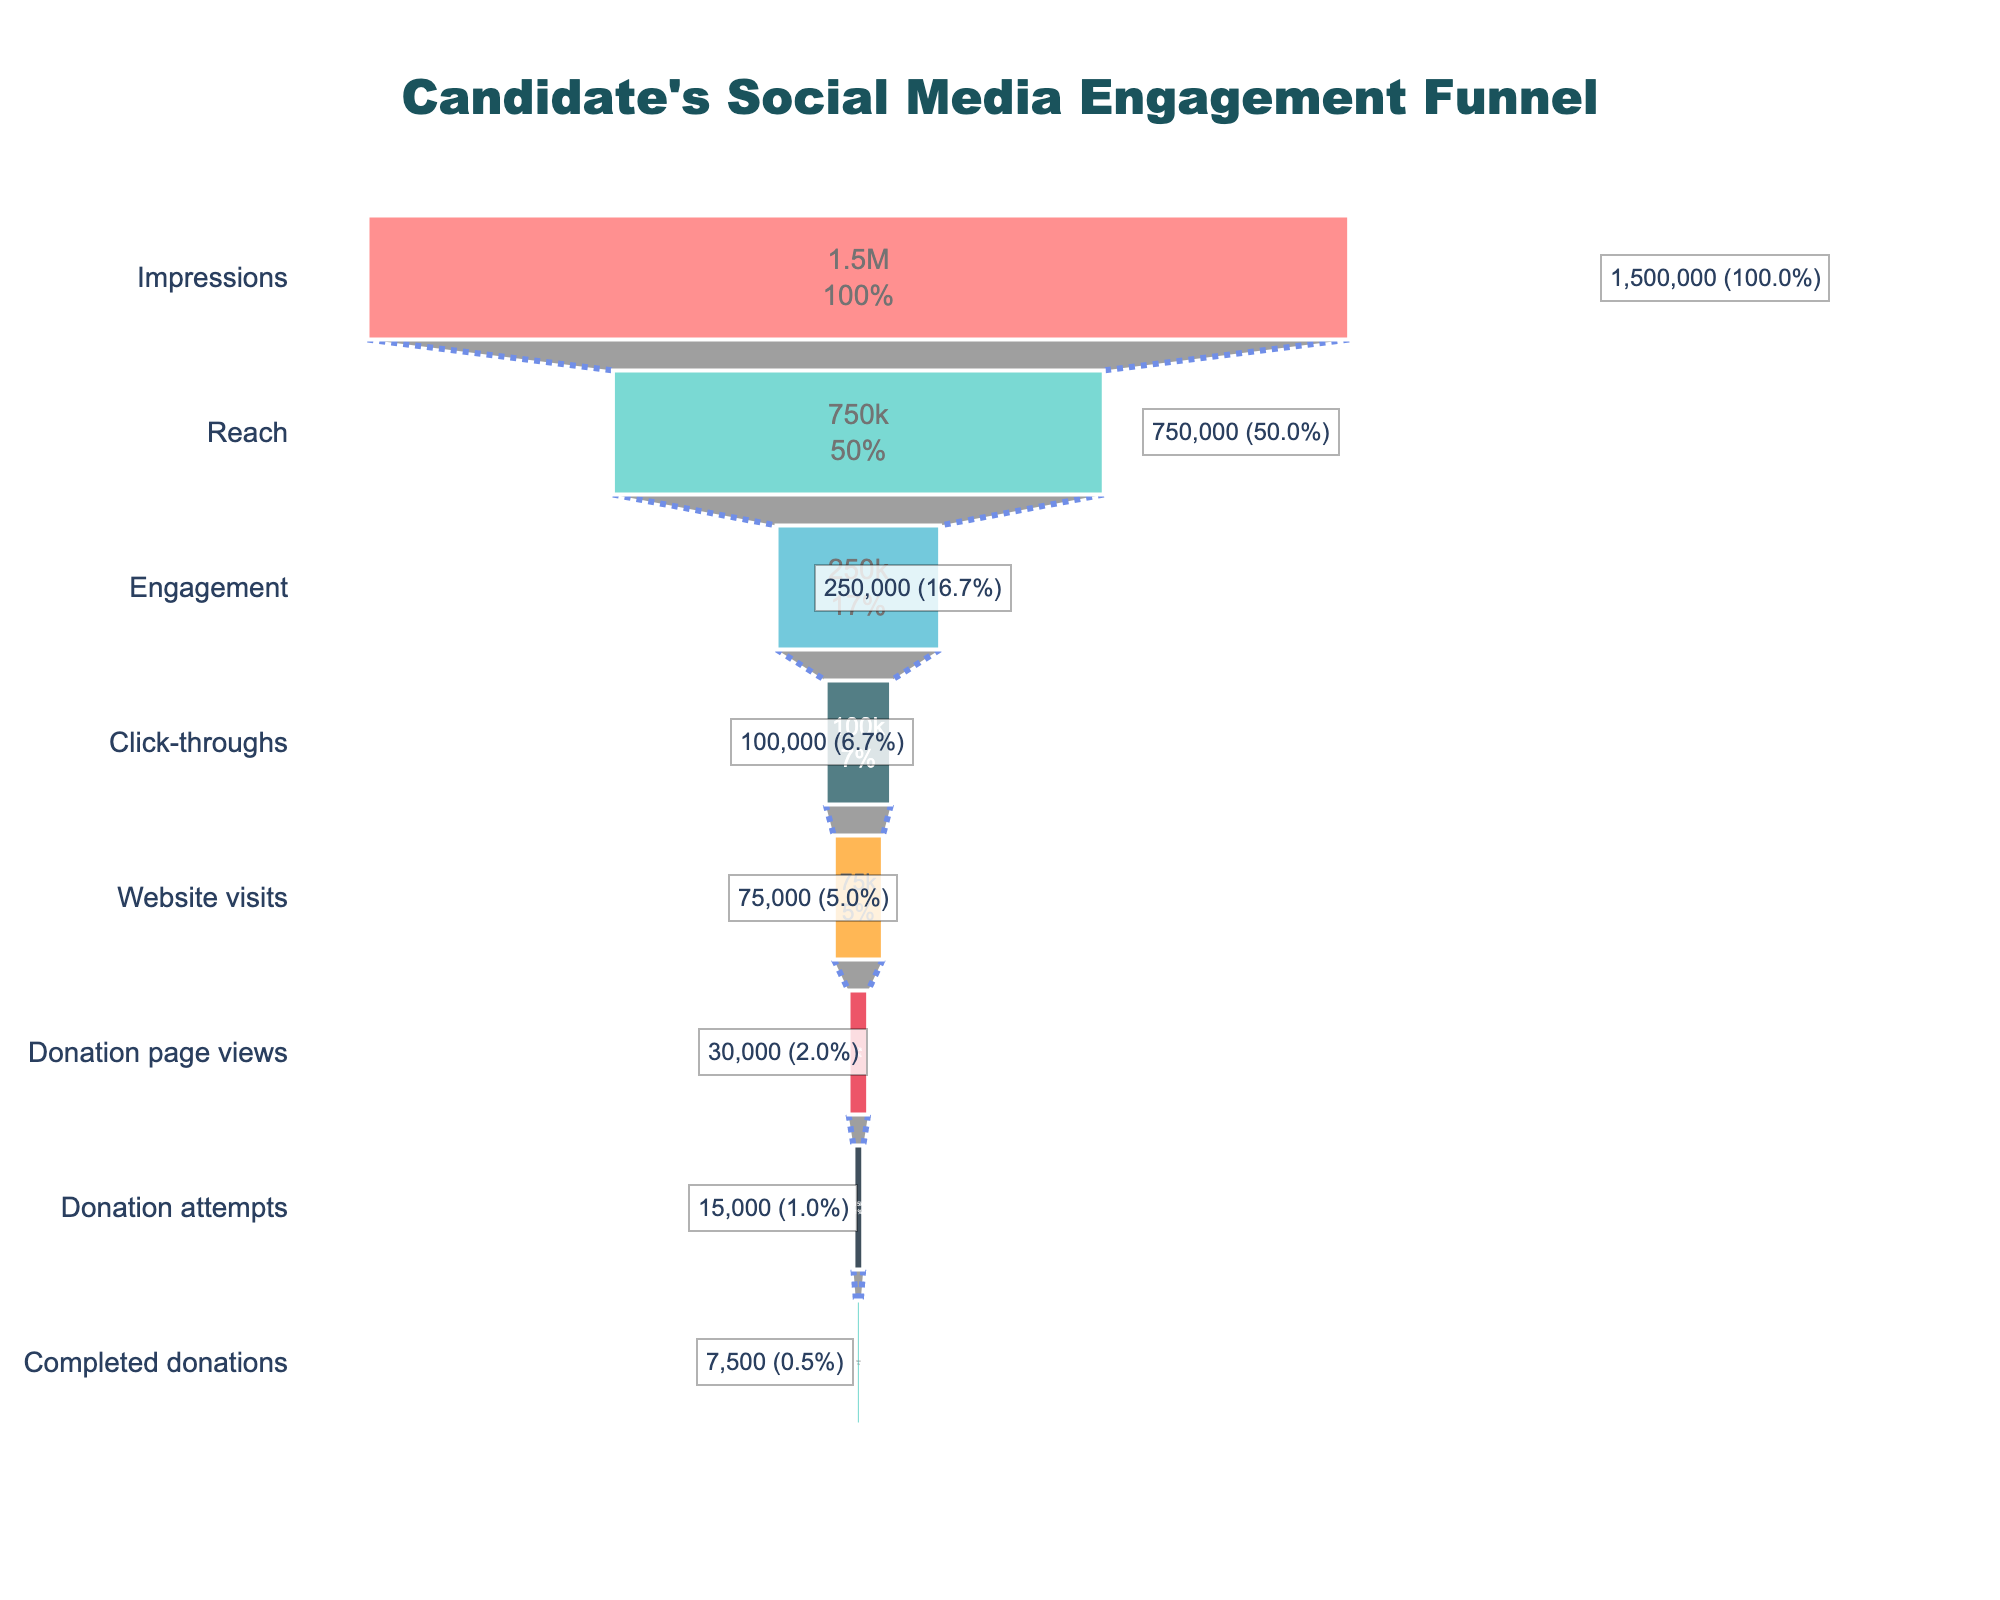what is the title of the figure? The title is displayed at the top of the chart and provides information about what the plot represents. In this case, the title reading "Candidate's Social Media Engagement Funnel" indicates the funnel for social media engagement of a candidate.
Answer: Candidate's Social Media Engagement Funnel What stage has the highest count? The stages are listed along the vertical axis, and the counts are displayed horizontally. The stage with the farthest reach on the horizontal axis represents the highest count. "Impressions" has the highest count as it stretches farthest.
Answer: Impressions How many completed donations were made? The completed donations are represented by the final stage at the bottom of the funnel. The count next to this stage reads "7,500."
Answer: 7,500 What percentage of impressions resulted in reach? Reach is the second stage in the funnel and impressions are the first stage. The reach count is 750,000 and impressions count is 1,500,000. To find the percentage, divide 750,000 by 1,500,000 and multiply by 100.
Answer: 50% Which stage shows a drop of 15,000 from its previous stage? Look sequentially to identify which stages have counts that differ by 15,000. The drop from "Donation page views" (30,000) to "Donation attempts" (15,000) is 15,000.
Answer: Donation attempts What percentage of website visits converted to donation page views? To find the conversion percentage, divide the count at "Donation page views" (30,000) by the count at "Website visits" (75,000) and multiply by 100.
Answer: 40% Which stage transitions are tied with the greatest percentage drop? Compute percentage drops between each subsequent pair of stages by subtracting counts of adjacent stages, dividing by the preceding stage's count, and finding the highest value. The transitions from "Click-throughs" (100,000) to "Website visits" (75,000) and from "Donation page views" (30,000) to "Donation attempts" (15,000) both result in a 25% drop.
Answer: Click-throughs to Website visits, Donation page views to Donation attempts 